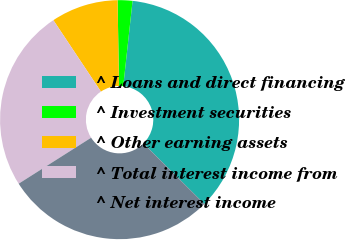Convert chart. <chart><loc_0><loc_0><loc_500><loc_500><pie_chart><fcel>^ Loans and direct financing<fcel>^ Investment securities<fcel>^ Other earning assets<fcel>^ Total interest income from<fcel>^ Net interest income<nl><fcel>35.73%<fcel>2.0%<fcel>9.08%<fcel>24.65%<fcel>28.54%<nl></chart> 